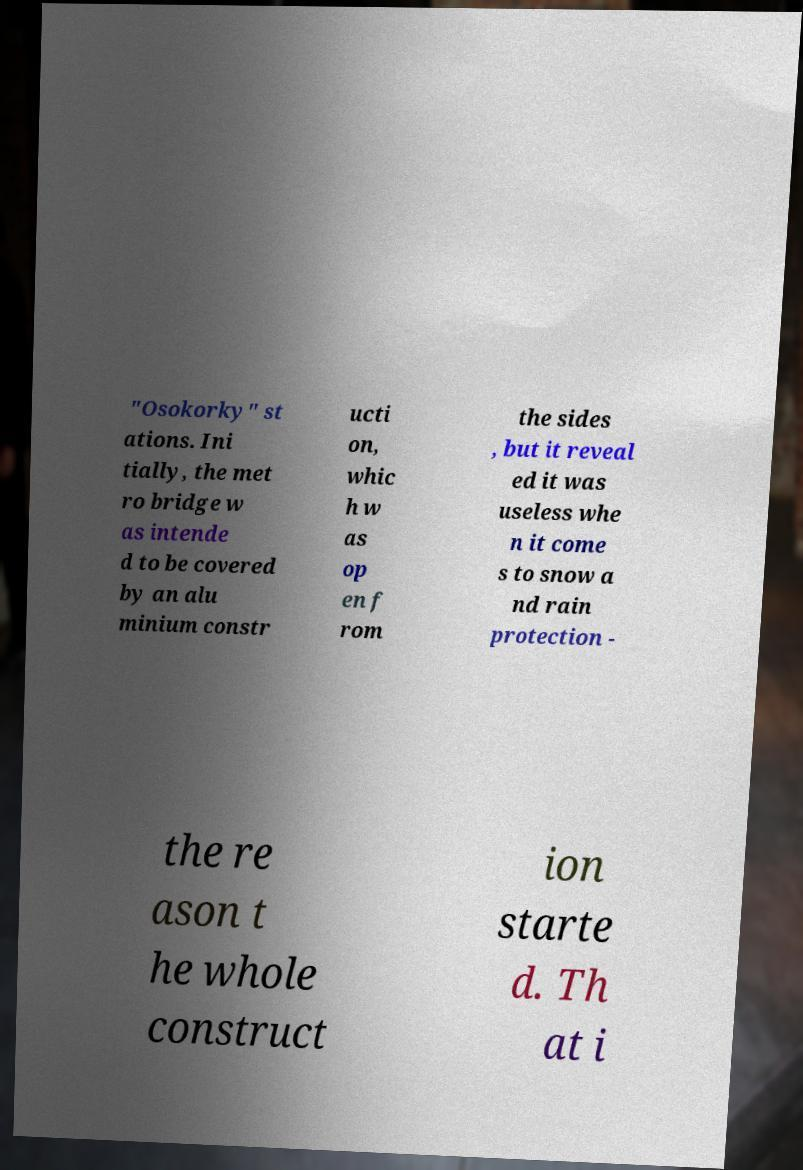Could you extract and type out the text from this image? "Osokorky" st ations. Ini tially, the met ro bridge w as intende d to be covered by an alu minium constr ucti on, whic h w as op en f rom the sides , but it reveal ed it was useless whe n it come s to snow a nd rain protection - the re ason t he whole construct ion starte d. Th at i 